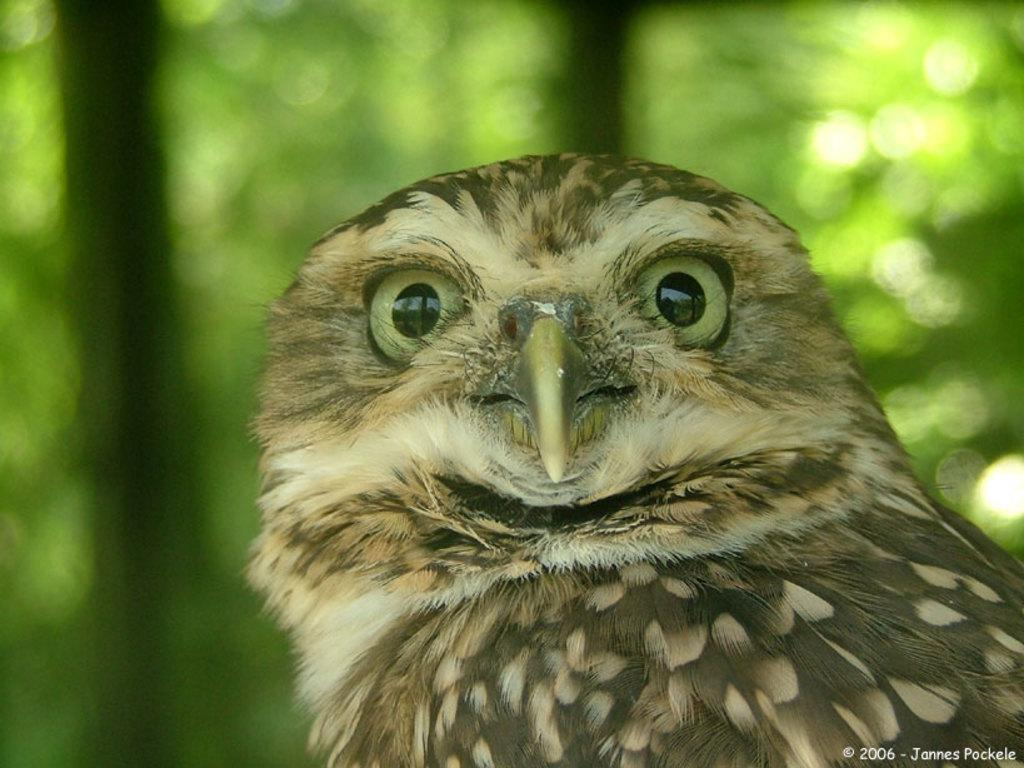What animal is in the picture? There is an owl in the picture. Can you describe the background of the picture? The background of the picture is blurred. Is there any additional information or marking on the image? Yes, there is a watermark on the image. What type of bean is being cooked by the owl's mother in the image? There is no bean or cooking activity depicted in the image, and the owl's mother is not present. What boundary is visible in the image? There is no boundary visible in the image; it features an owl and a blurred background. 